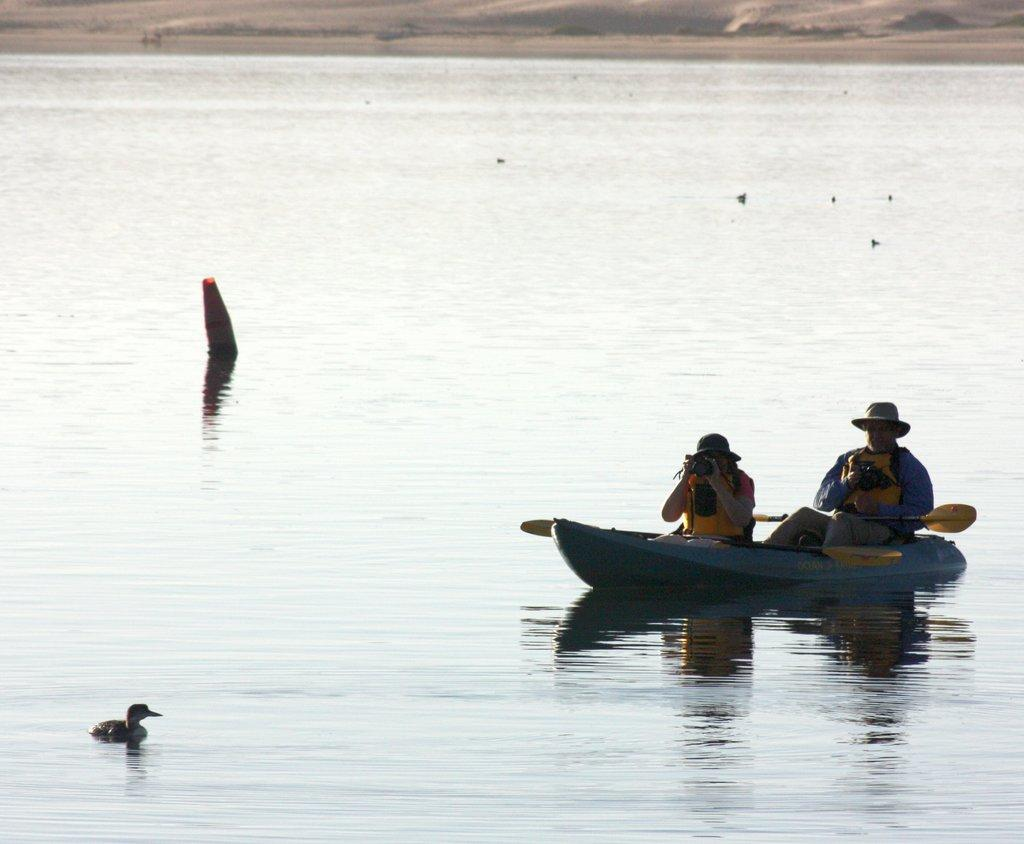How many people are in the image? There are two persons in the image. What are the persons doing in the image? The persons are sitting in a boat. Where is the boat located in the image? The boat is on water. What is one of the persons holding in the image? One of the persons is holding a camera. What type of thought can be seen floating in the water near the boat? There is no thought visible in the image; it only shows two persons sitting in a boat on water. 